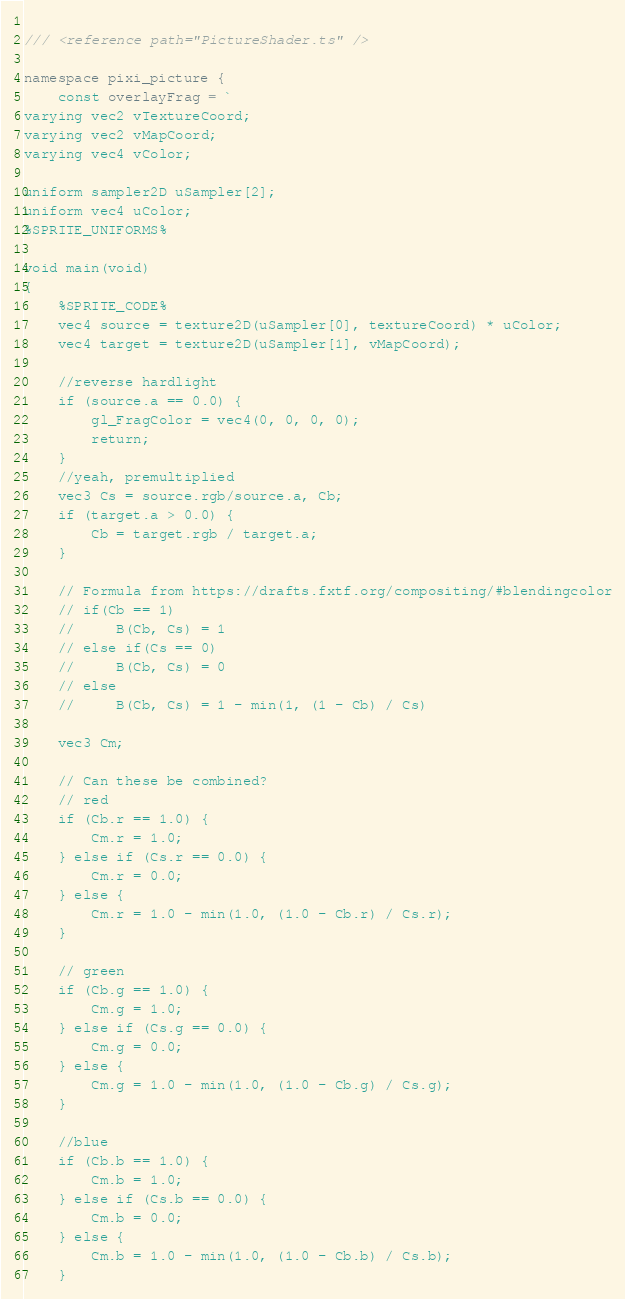<code> <loc_0><loc_0><loc_500><loc_500><_TypeScript_>	
/// <reference path="PictureShader.ts" />

namespace pixi_picture {
	const overlayFrag = `
varying vec2 vTextureCoord;
varying vec2 vMapCoord;
varying vec4 vColor;

uniform sampler2D uSampler[2];
uniform vec4 uColor;
%SPRITE_UNIFORMS%

void main(void)
{
    %SPRITE_CODE%
    vec4 source = texture2D(uSampler[0], textureCoord) * uColor;
    vec4 target = texture2D(uSampler[1], vMapCoord);

    //reverse hardlight
    if (source.a == 0.0) {
        gl_FragColor = vec4(0, 0, 0, 0);
        return;
    }
    //yeah, premultiplied
    vec3 Cs = source.rgb/source.a, Cb;
    if (target.a > 0.0) {
        Cb = target.rgb / target.a;
	}
	
	// Formula from https://drafts.fxtf.org/compositing/#blendingcolor
	// if(Cb == 1)
	//     B(Cb, Cs) = 1
	// else if(Cs == 0)
	//     B(Cb, Cs) = 0
	// else
	//     B(Cb, Cs) = 1 - min(1, (1 - Cb) / Cs)

	vec3 Cm;

	// Can these be combined?
	// red
	if (Cb.r == 1.0) {
		Cm.r = 1.0;
	} else if (Cs.r == 0.0) {
		Cm.r = 0.0;
	} else {
		Cm.r = 1.0 - min(1.0, (1.0 - Cb.r) / Cs.r);
	}

	// green
	if (Cb.g == 1.0) {
		Cm.g = 1.0;
	} else if (Cs.g == 0.0) {
		Cm.g = 0.0;
	} else {
		Cm.g = 1.0 - min(1.0, (1.0 - Cb.g) / Cs.g);
	}

	//blue
	if (Cb.b == 1.0) {
		Cm.b = 1.0;
	} else if (Cs.b == 0.0) {
		Cm.b = 0.0;
	} else {
		Cm.b = 1.0 - min(1.0, (1.0 - Cb.b) / Cs.b);
	}
</code> 